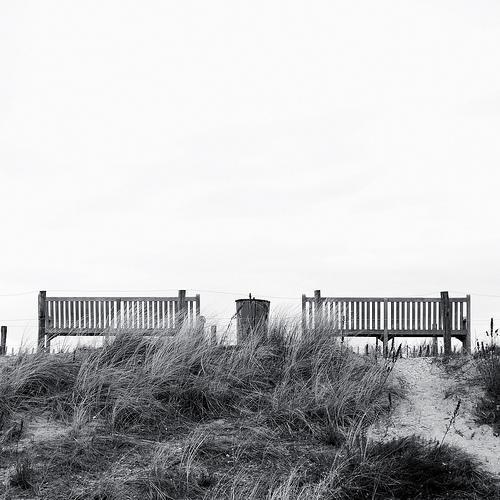How many benches are shown?
Give a very brief answer. 2. How many trash cans are there?
Give a very brief answer. 1. 